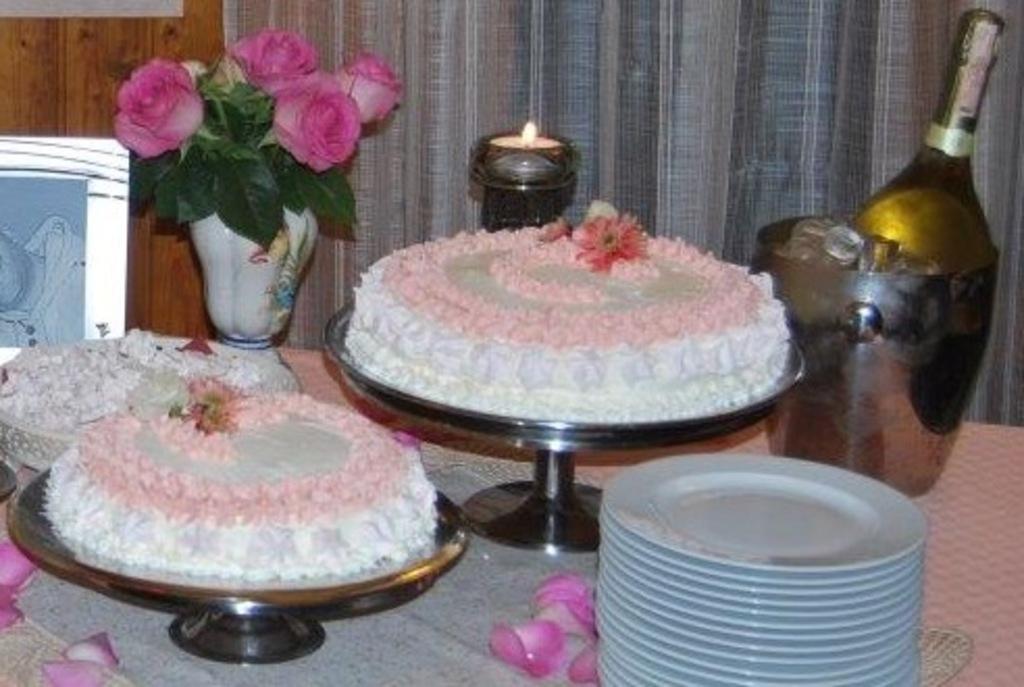Could you give a brief overview of what you see in this image? In this image we can see some cakes, plates, flower pot, wine bottle and ice cubes in a bowl and some other objects on the table, in the background we can see a curtain and the wooden wall. 